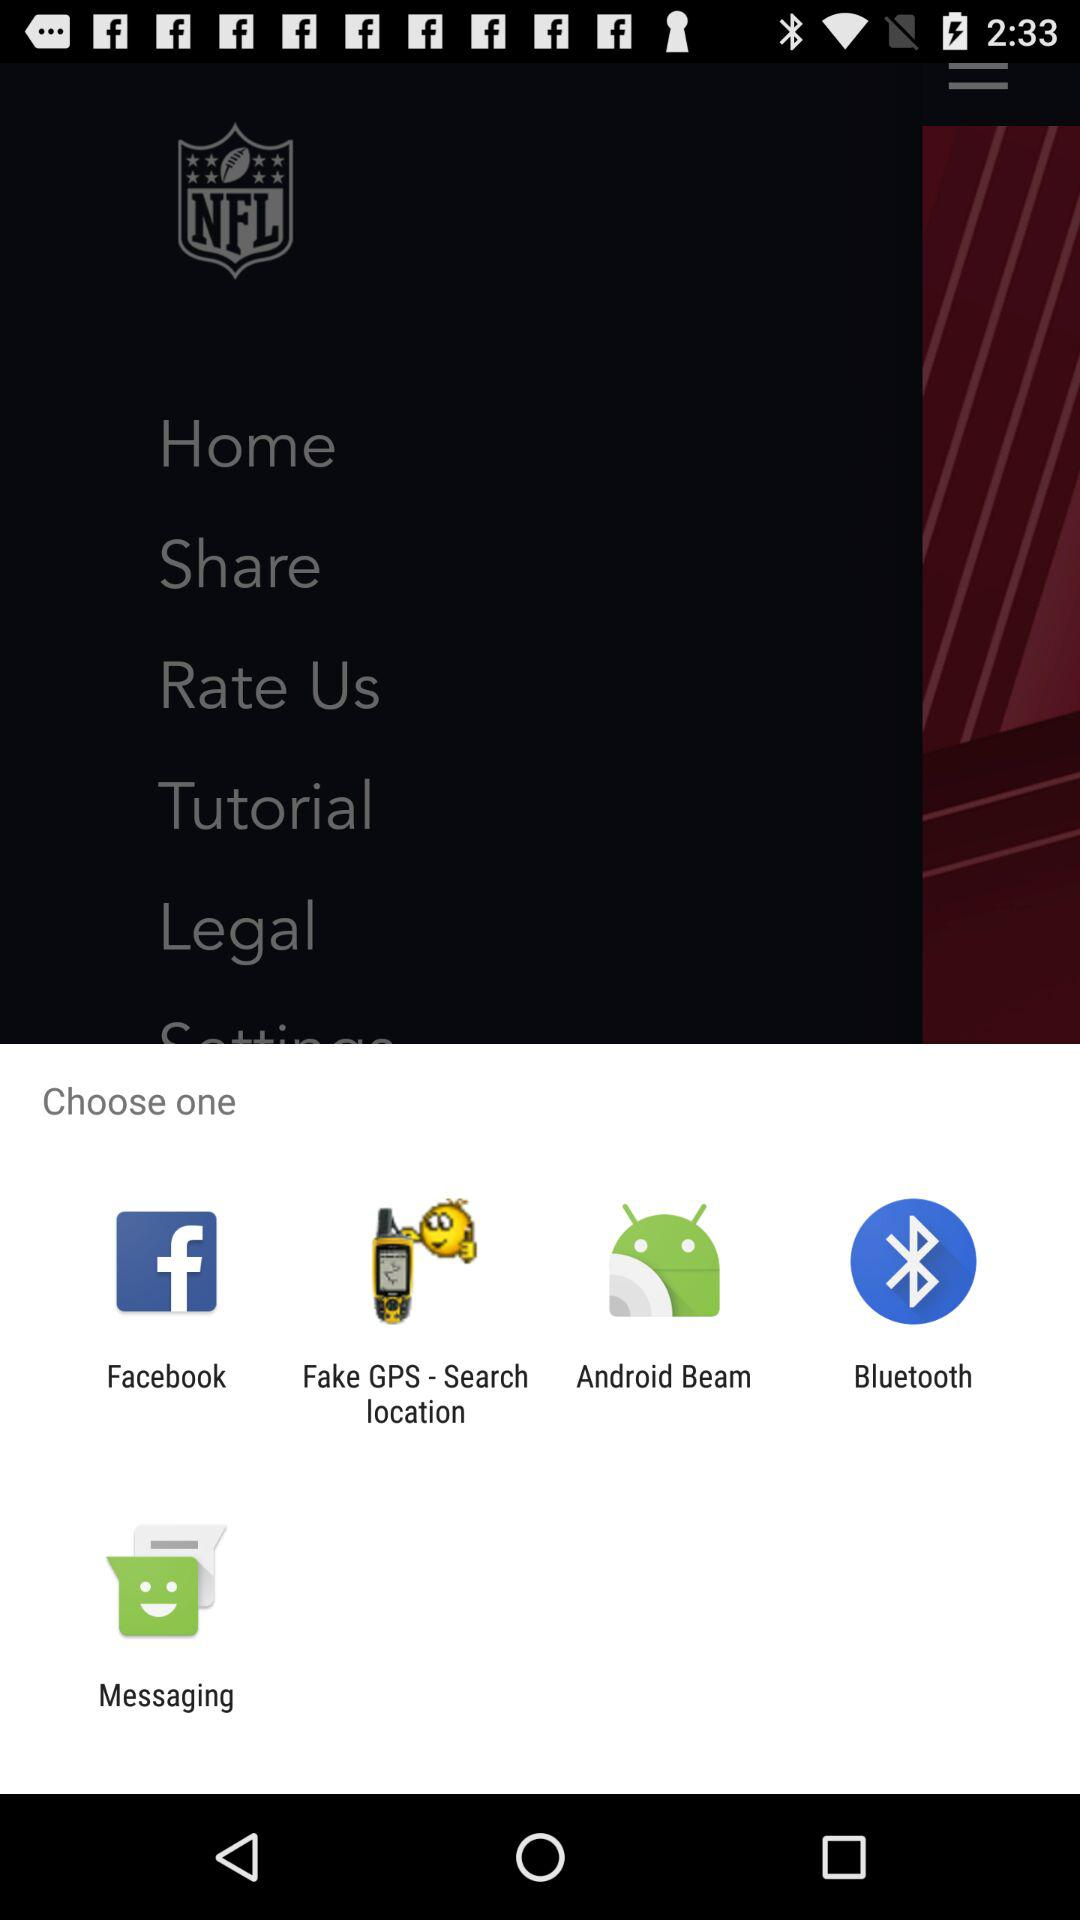Through which app can I share the content? You can share the content through "Facebook", "Fake GPS - Search location", "Android Beam", "Bluetooth" and "Messaging". 